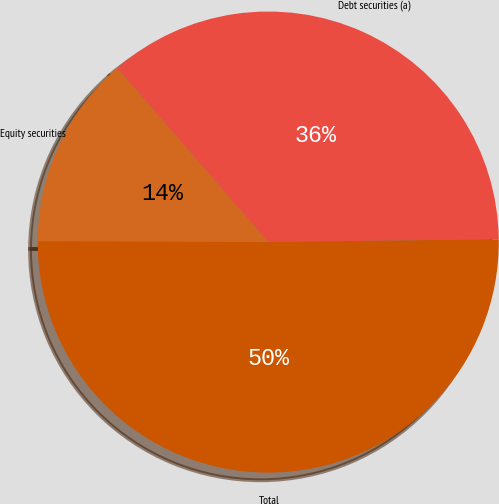Convert chart to OTSL. <chart><loc_0><loc_0><loc_500><loc_500><pie_chart><fcel>Debt securities (a)<fcel>Equity securities<fcel>Total<nl><fcel>36.18%<fcel>13.57%<fcel>50.25%<nl></chart> 